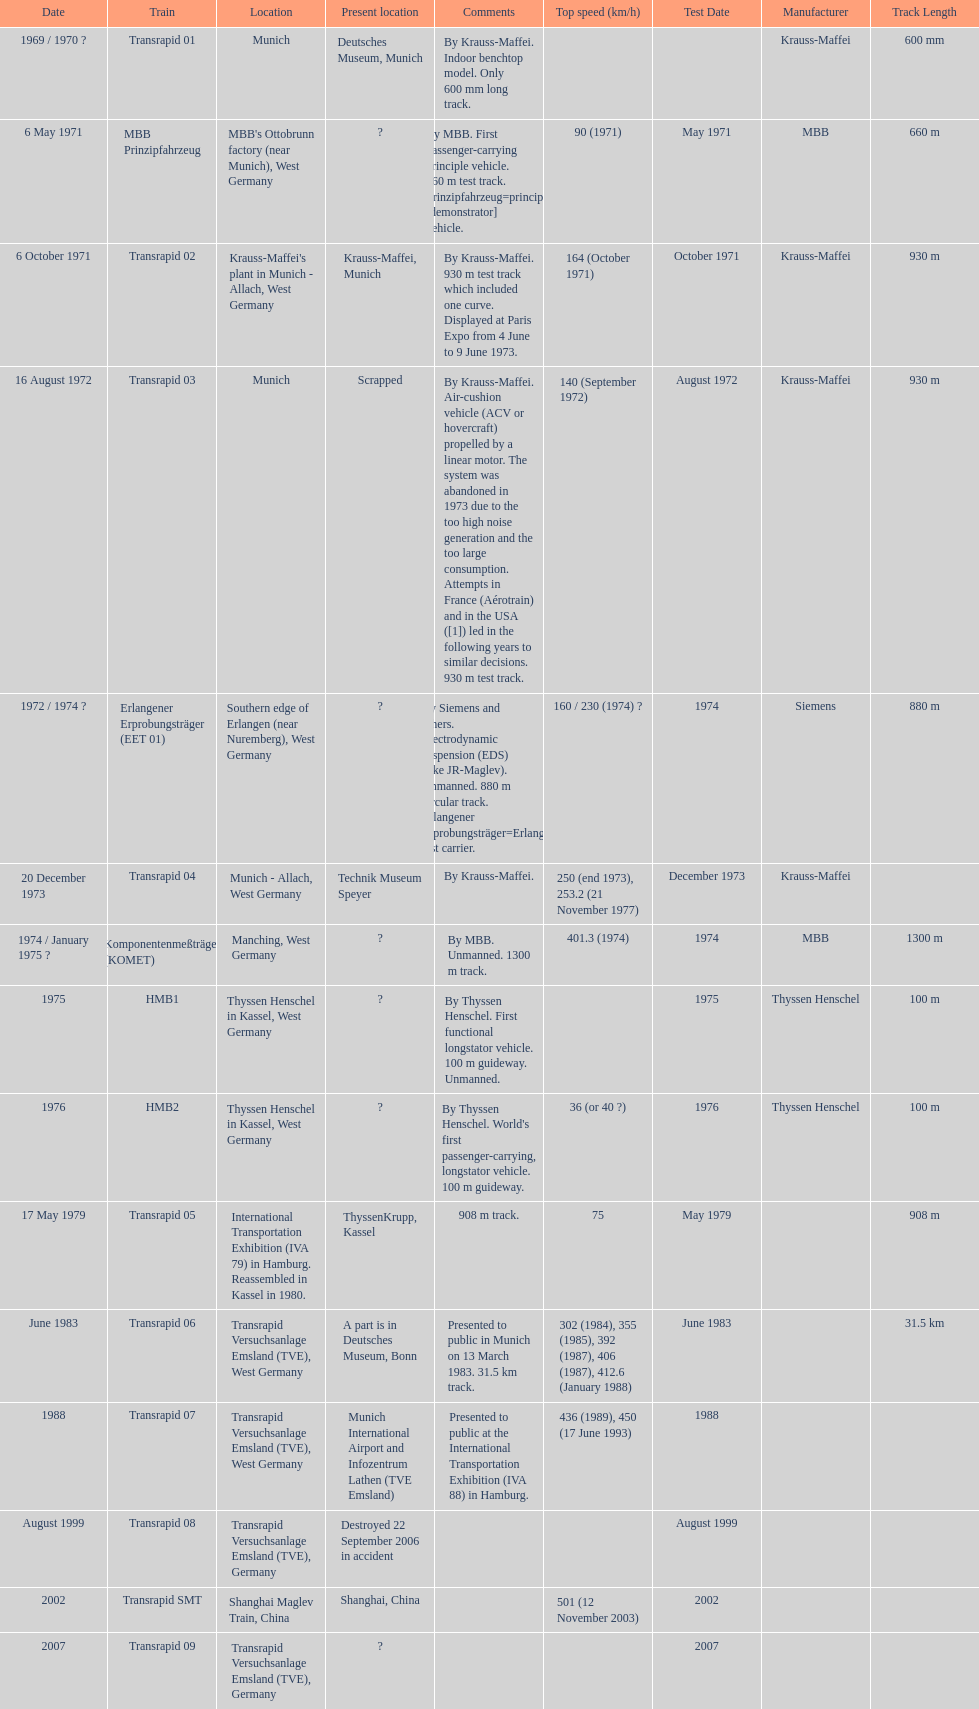What is the only train to reach a top speed of 500 or more? Transrapid SMT. 